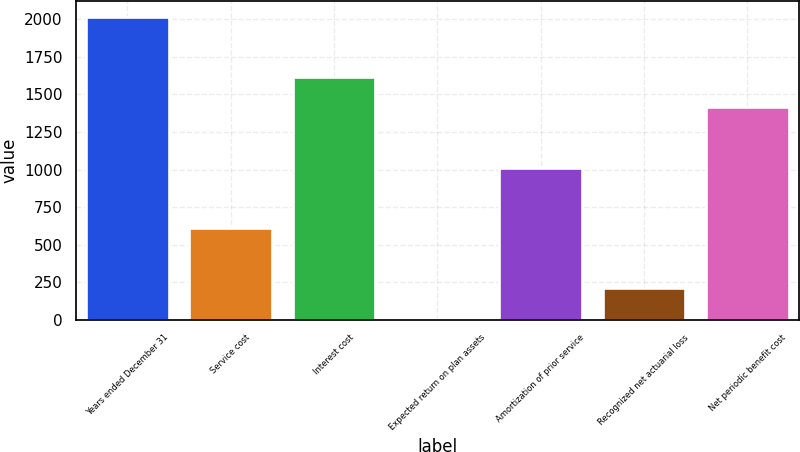<chart> <loc_0><loc_0><loc_500><loc_500><bar_chart><fcel>Years ended December 31<fcel>Service cost<fcel>Interest cost<fcel>Expected return on plan assets<fcel>Amortization of prior service<fcel>Recognized net actuarial loss<fcel>Net periodic benefit cost<nl><fcel>2018<fcel>611<fcel>1616<fcel>8<fcel>1013<fcel>209<fcel>1415<nl></chart> 